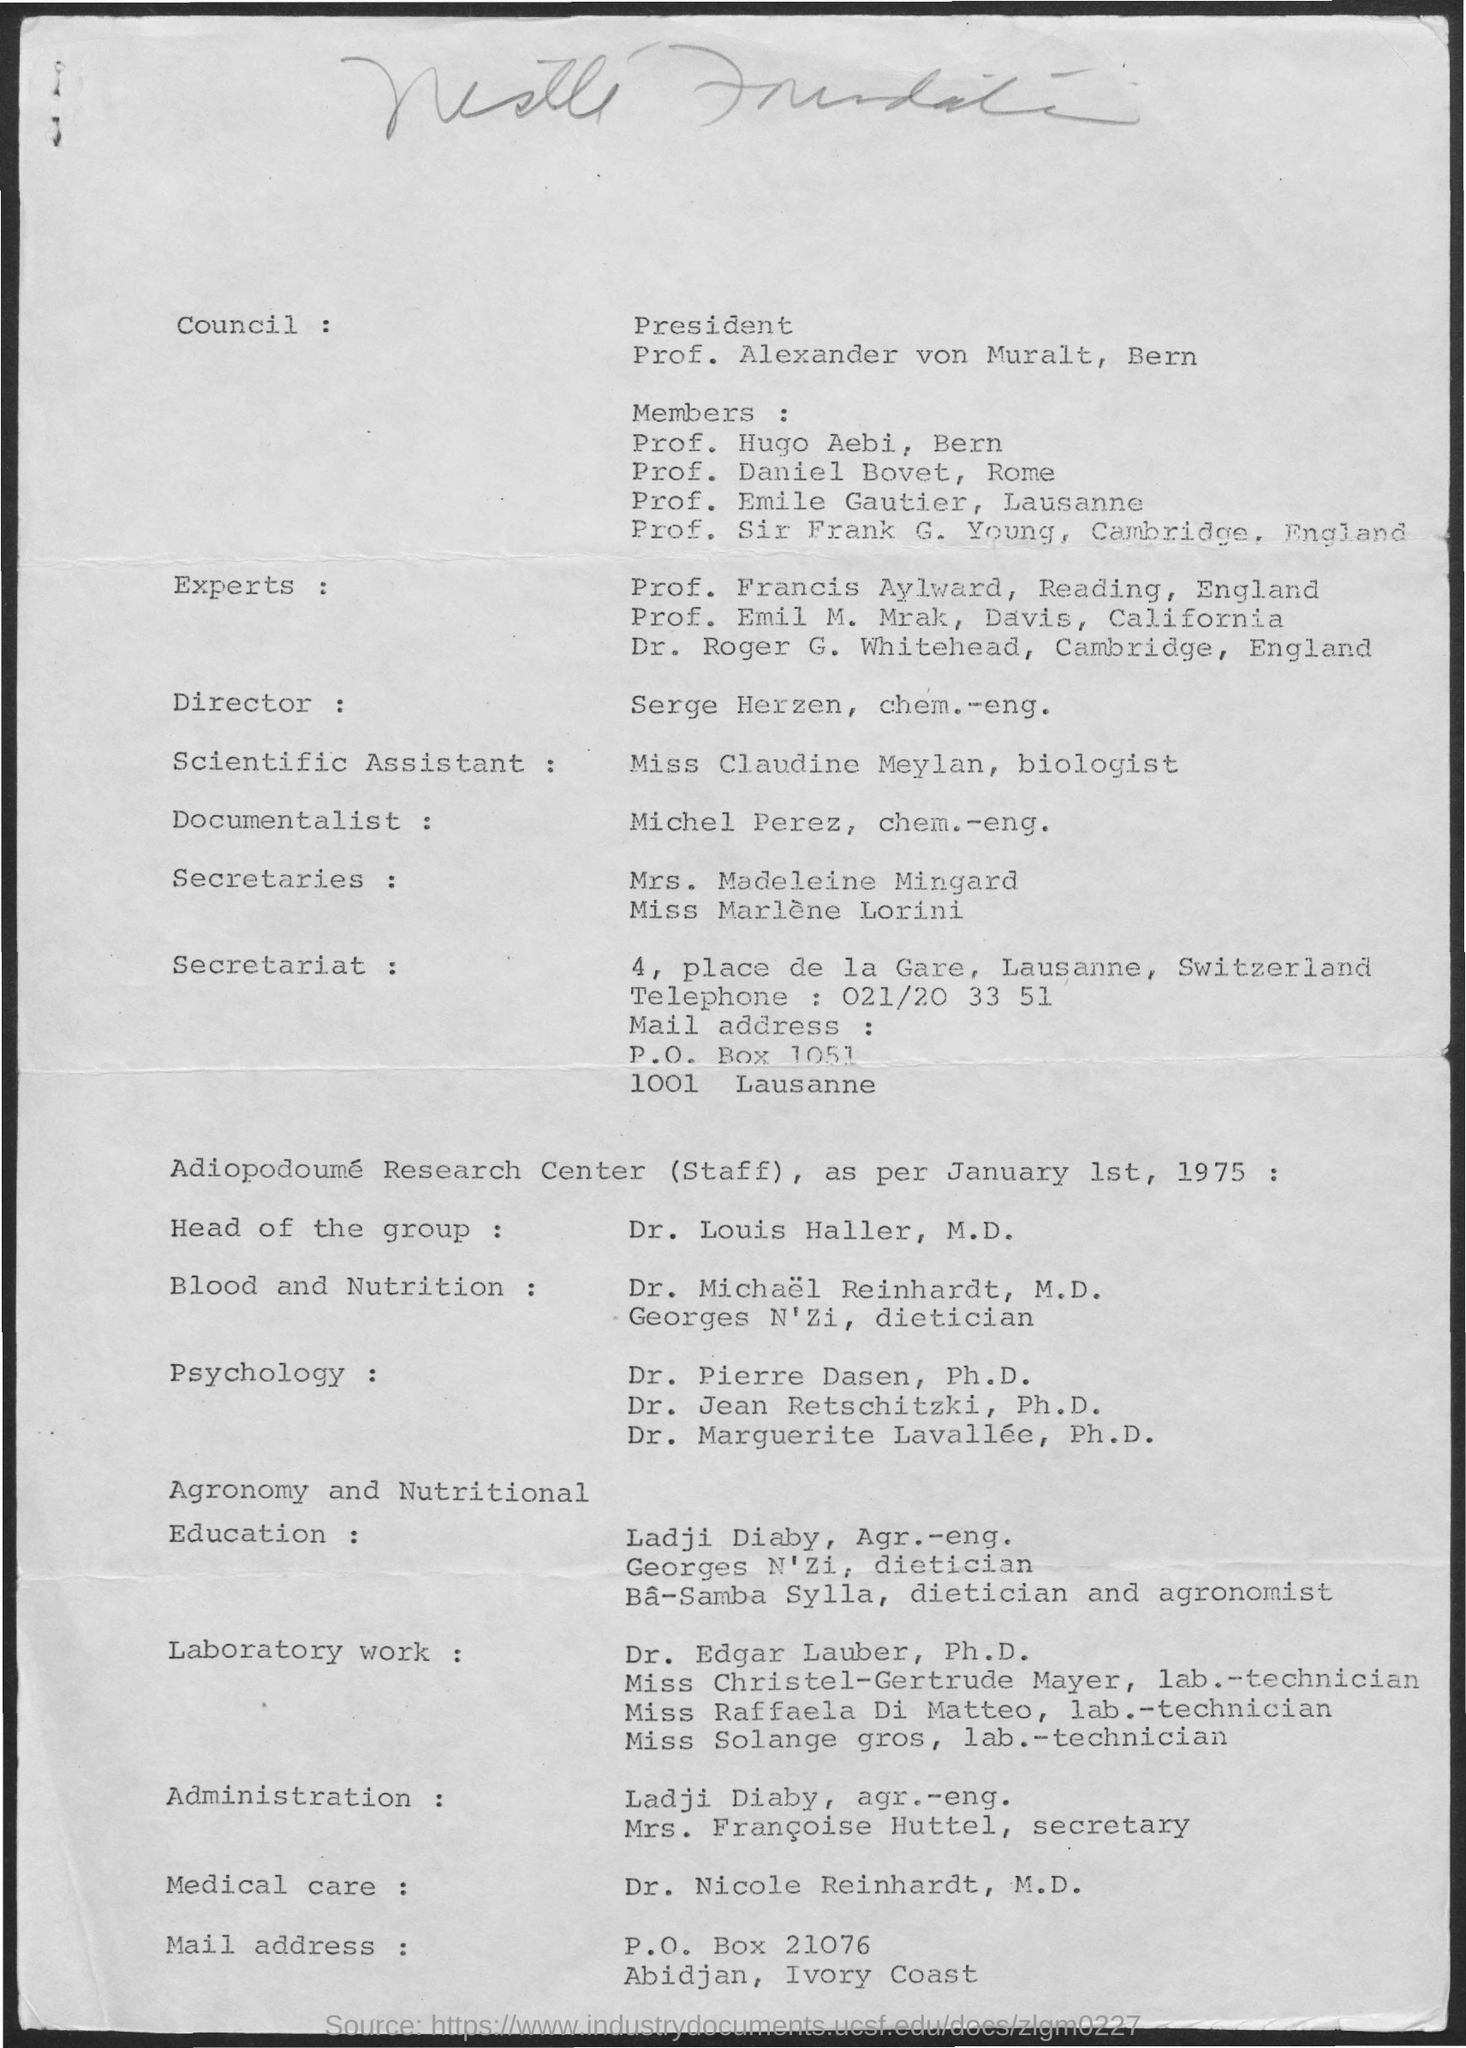Indicate a few pertinent items in this graphic. Cambridge is located in the country of England. The telephone number of the secretariat is 021/20 33 51. The director's name is Sergei Herz. The documentalist is Michel Perez. The document mentions that the date is January 1st, 1975. 